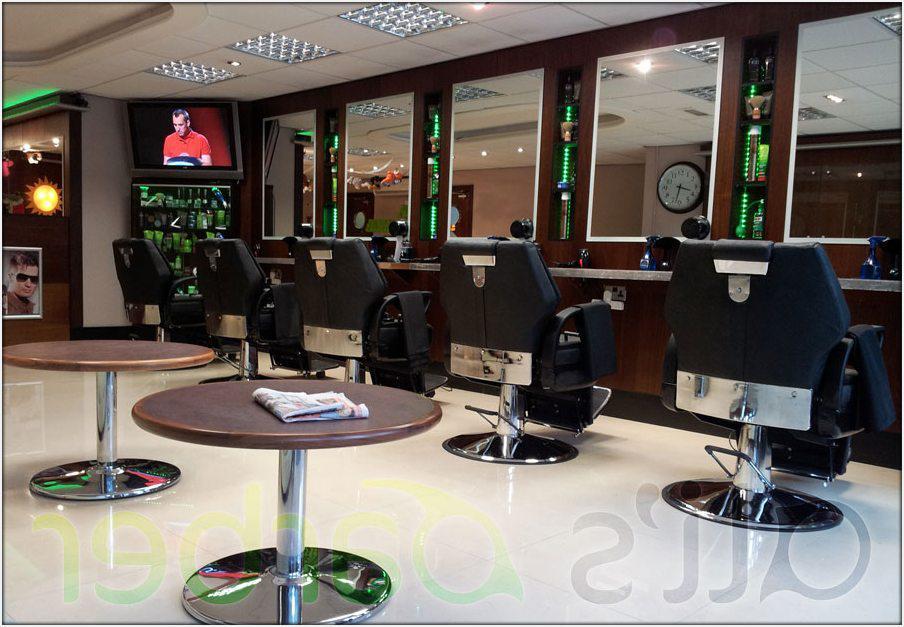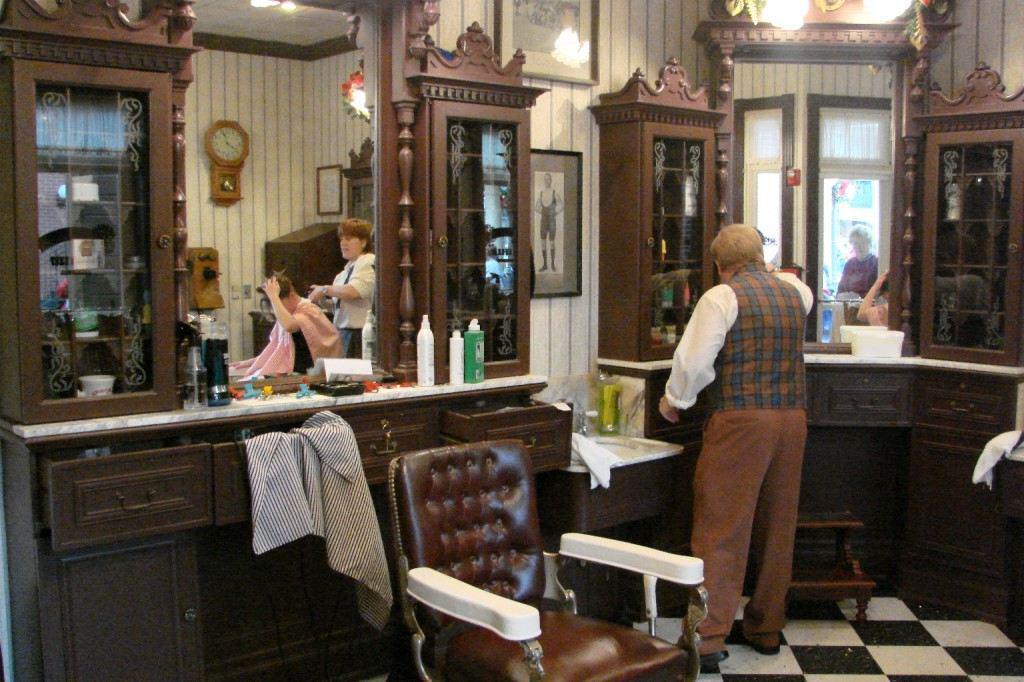The first image is the image on the left, the second image is the image on the right. Assess this claim about the two images: "The left and right image contains the same number chairs.". Correct or not? Answer yes or no. No. The first image is the image on the left, the second image is the image on the right. Given the left and right images, does the statement "The left image features at least one empty back-turned black barber chair in front of a rectangular mirror." hold true? Answer yes or no. Yes. 